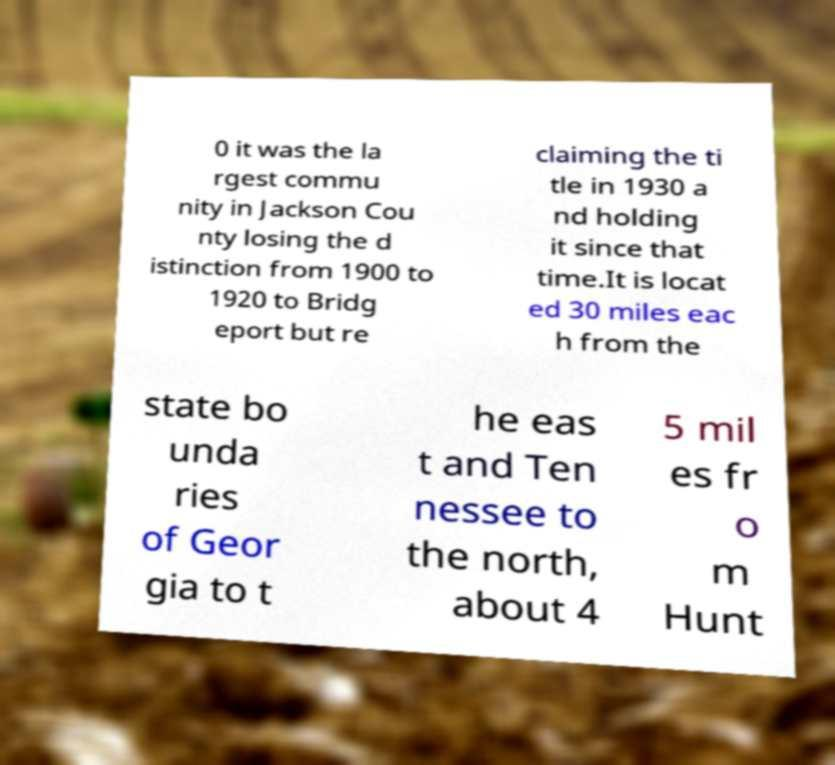I need the written content from this picture converted into text. Can you do that? 0 it was the la rgest commu nity in Jackson Cou nty losing the d istinction from 1900 to 1920 to Bridg eport but re claiming the ti tle in 1930 a nd holding it since that time.It is locat ed 30 miles eac h from the state bo unda ries of Geor gia to t he eas t and Ten nessee to the north, about 4 5 mil es fr o m Hunt 